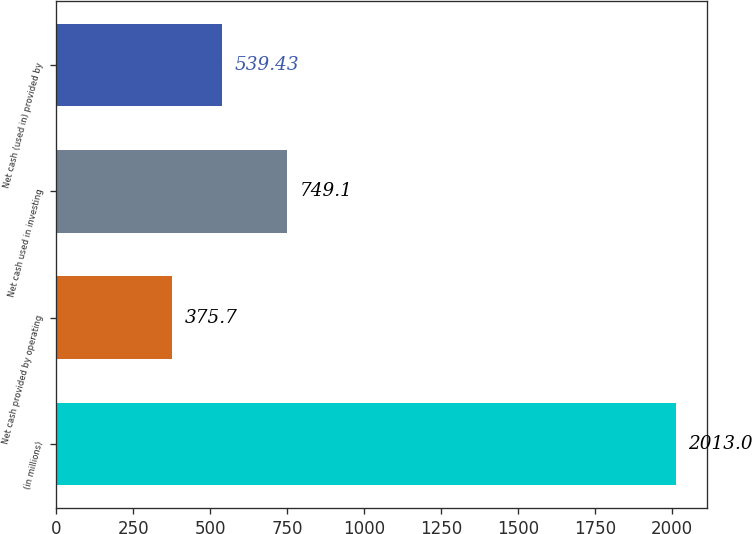Convert chart to OTSL. <chart><loc_0><loc_0><loc_500><loc_500><bar_chart><fcel>(in millions)<fcel>Net cash provided by operating<fcel>Net cash used in investing<fcel>Net cash (used in) provided by<nl><fcel>2013<fcel>375.7<fcel>749.1<fcel>539.43<nl></chart> 